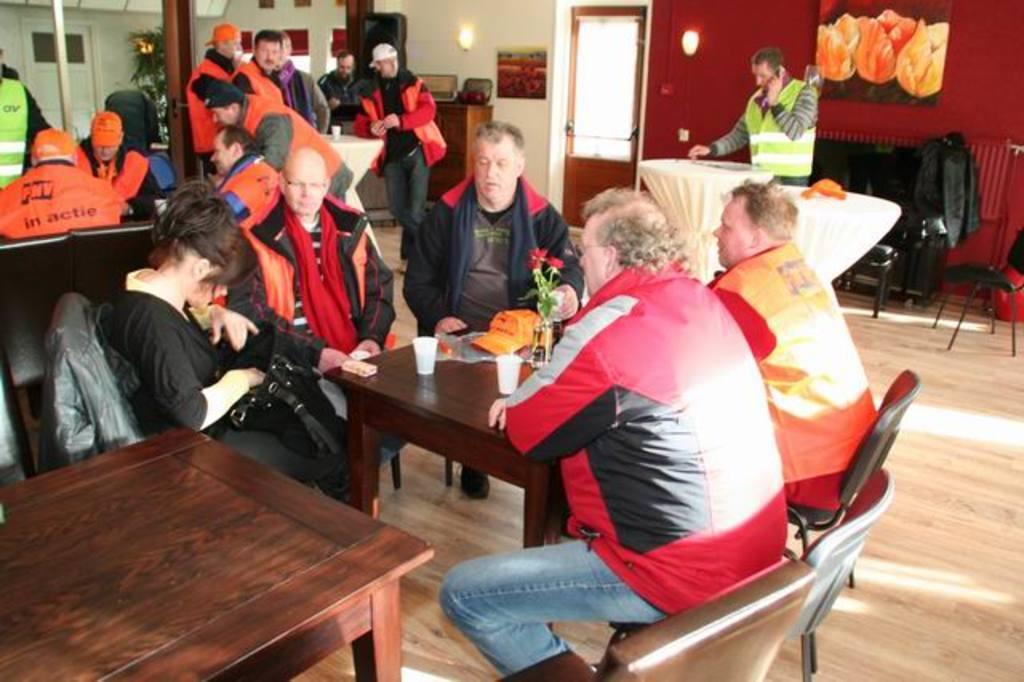Please provide a concise description of this image. Few persons are sitting on the chairs and few persons are standing,this person holding telephone. On the background we can see wall,lights,door,frame,tree. We can see tables and chairs,on the table we can see glasses,cap,flower. This is floor. 